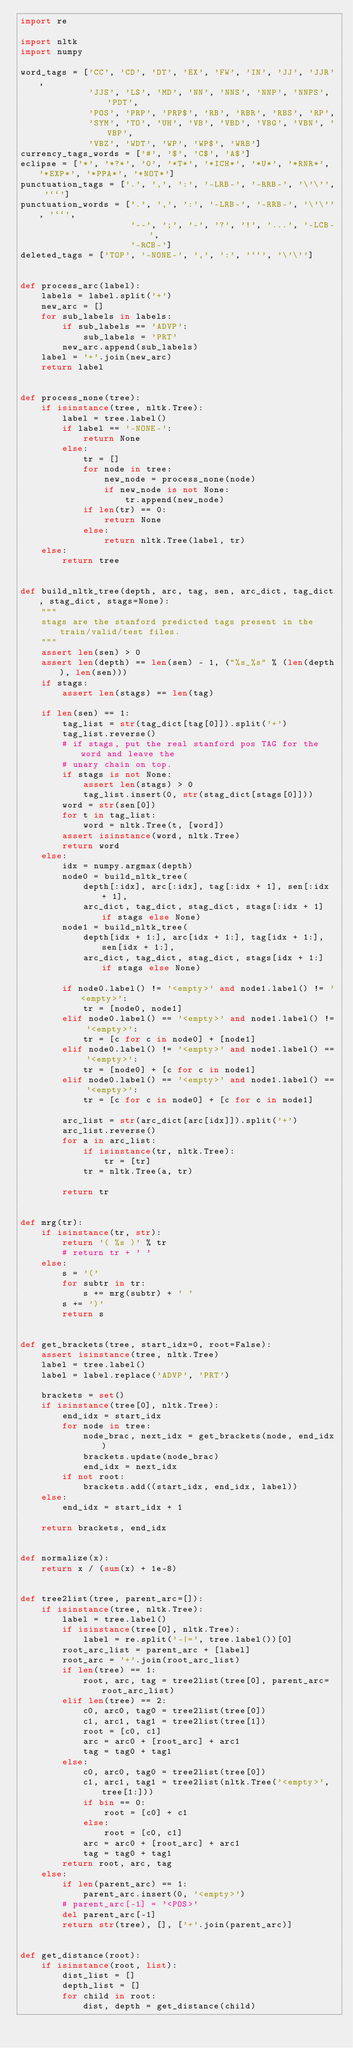<code> <loc_0><loc_0><loc_500><loc_500><_Python_>import re

import nltk
import numpy

word_tags = ['CC', 'CD', 'DT', 'EX', 'FW', 'IN', 'JJ', 'JJR',
             'JJS', 'LS', 'MD', 'NN', 'NNS', 'NNP', 'NNPS', 'PDT',
             'POS', 'PRP', 'PRP$', 'RB', 'RBR', 'RBS', 'RP',
             'SYM', 'TO', 'UH', 'VB', 'VBD', 'VBG', 'VBN', 'VBP',
             'VBZ', 'WDT', 'WP', 'WP$', 'WRB']
currency_tags_words = ['#', '$', 'C$', 'A$']
eclipse = ['*', '*?*', '0', '*T*', '*ICH*', '*U*', '*RNR*', '*EXP*', '*PPA*', '*NOT*']
punctuation_tags = ['.', ',', ':', '-LRB-', '-RRB-', '\'\'', '``']
punctuation_words = ['.', ',', ':', '-LRB-', '-RRB-', '\'\'', '``',
                     '--', ';', '-', '?', '!', '...', '-LCB-',
                     '-RCB-']
deleted_tags = ['TOP', '-NONE-', ',', ':', '``', '\'\'']


def process_arc(label):
    labels = label.split('+')
    new_arc = []
    for sub_labels in labels:
        if sub_labels == 'ADVP':
            sub_labels = 'PRT'
        new_arc.append(sub_labels)
    label = '+'.join(new_arc)
    return label


def process_none(tree):
    if isinstance(tree, nltk.Tree):
        label = tree.label()
        if label == '-NONE-':
            return None
        else:
            tr = []
            for node in tree:
                new_node = process_none(node)
                if new_node is not None:
                    tr.append(new_node)
            if len(tr) == 0:
                return None
            else:
                return nltk.Tree(label, tr)
    else:
        return tree


def build_nltk_tree(depth, arc, tag, sen, arc_dict, tag_dict, stag_dict, stags=None):
    """
    stags are the stanford predicted tags present in the train/valid/test files.
    """
    assert len(sen) > 0
    assert len(depth) == len(sen) - 1, ("%s_%s" % (len(depth), len(sen)))
    if stags:
        assert len(stags) == len(tag)

    if len(sen) == 1:
        tag_list = str(tag_dict[tag[0]]).split('+')
        tag_list.reverse()
        # if stags, put the real stanford pos TAG for the word and leave the
        # unary chain on top.
        if stags is not None:
            assert len(stags) > 0
            tag_list.insert(0, str(stag_dict[stags[0]]))
        word = str(sen[0])
        for t in tag_list:
            word = nltk.Tree(t, [word])
        assert isinstance(word, nltk.Tree)
        return word
    else:
        idx = numpy.argmax(depth)
        node0 = build_nltk_tree(
            depth[:idx], arc[:idx], tag[:idx + 1], sen[:idx + 1],
            arc_dict, tag_dict, stag_dict, stags[:idx + 1] if stags else None)
        node1 = build_nltk_tree(
            depth[idx + 1:], arc[idx + 1:], tag[idx + 1:], sen[idx + 1:],
            arc_dict, tag_dict, stag_dict, stags[idx + 1:] if stags else None)

        if node0.label() != '<empty>' and node1.label() != '<empty>':
            tr = [node0, node1]
        elif node0.label() == '<empty>' and node1.label() != '<empty>':
            tr = [c for c in node0] + [node1]
        elif node0.label() != '<empty>' and node1.label() == '<empty>':
            tr = [node0] + [c for c in node1]
        elif node0.label() == '<empty>' and node1.label() == '<empty>':
            tr = [c for c in node0] + [c for c in node1]

        arc_list = str(arc_dict[arc[idx]]).split('+')
        arc_list.reverse()
        for a in arc_list:
            if isinstance(tr, nltk.Tree):
                tr = [tr]
            tr = nltk.Tree(a, tr)

        return tr


def mrg(tr):
    if isinstance(tr, str):
        return '( %s )' % tr
        # return tr + ' '
    else:
        s = '('
        for subtr in tr:
            s += mrg(subtr) + ' '
        s += ')'
        return s


def get_brackets(tree, start_idx=0, root=False):
    assert isinstance(tree, nltk.Tree)
    label = tree.label()
    label = label.replace('ADVP', 'PRT')

    brackets = set()
    if isinstance(tree[0], nltk.Tree):
        end_idx = start_idx
        for node in tree:
            node_brac, next_idx = get_brackets(node, end_idx)
            brackets.update(node_brac)
            end_idx = next_idx
        if not root:
            brackets.add((start_idx, end_idx, label))
    else:
        end_idx = start_idx + 1

    return brackets, end_idx


def normalize(x):
    return x / (sum(x) + 1e-8)


def tree2list(tree, parent_arc=[]):
    if isinstance(tree, nltk.Tree):
        label = tree.label()
        if isinstance(tree[0], nltk.Tree):
            label = re.split('-|=', tree.label())[0]
        root_arc_list = parent_arc + [label]
        root_arc = '+'.join(root_arc_list)
        if len(tree) == 1:
            root, arc, tag = tree2list(tree[0], parent_arc=root_arc_list)
        elif len(tree) == 2:
            c0, arc0, tag0 = tree2list(tree[0])
            c1, arc1, tag1 = tree2list(tree[1])
            root = [c0, c1]
            arc = arc0 + [root_arc] + arc1
            tag = tag0 + tag1
        else:
            c0, arc0, tag0 = tree2list(tree[0])
            c1, arc1, tag1 = tree2list(nltk.Tree('<empty>', tree[1:]))
            if bin == 0:
                root = [c0] + c1
            else:
                root = [c0, c1]
            arc = arc0 + [root_arc] + arc1
            tag = tag0 + tag1
        return root, arc, tag
    else:
        if len(parent_arc) == 1:
            parent_arc.insert(0, '<empty>')
        # parent_arc[-1] = '<POS>'
        del parent_arc[-1]
        return str(tree), [], ['+'.join(parent_arc)]


def get_distance(root):
    if isinstance(root, list):
        dist_list = []
        depth_list = []
        for child in root:
            dist, depth = get_distance(child)</code> 